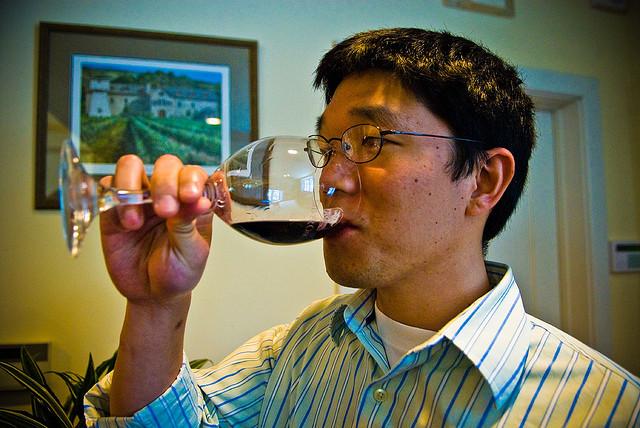Is the man wearing a tie?
Quick response, please. No. What is the brand of drink?
Concise answer only. Wine. What is the man drinking?
Answer briefly. Wine. What animal does the drink depict?
Keep it brief. None. What part of the world do this man's ancestors appear to be from?
Write a very short answer. Asia. 